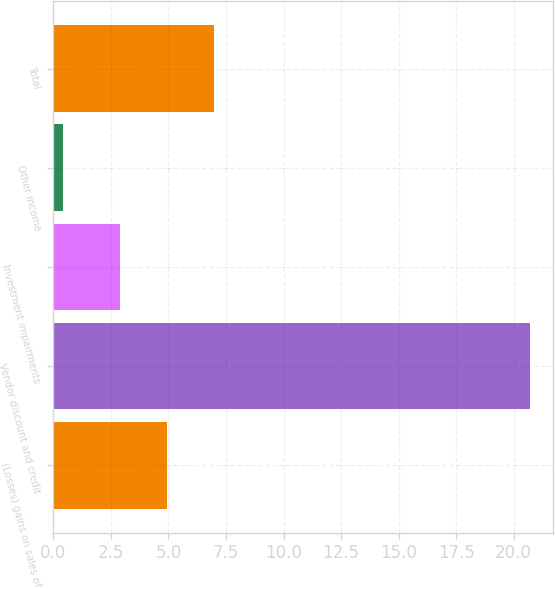<chart> <loc_0><loc_0><loc_500><loc_500><bar_chart><fcel>(Losses) gains on sales of<fcel>Vendor discount and credit<fcel>Investment impairments<fcel>Other income<fcel>Total<nl><fcel>4.93<fcel>20.7<fcel>2.9<fcel>0.4<fcel>6.96<nl></chart> 